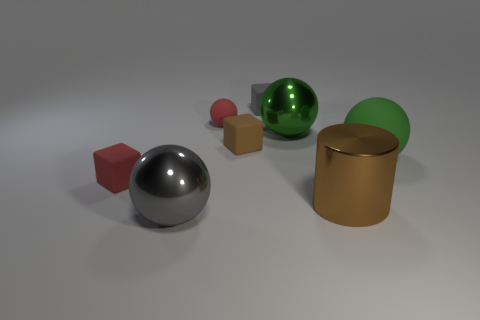Subtract all brown cylinders. How many green spheres are left? 2 Subtract all red balls. How many balls are left? 3 Subtract all tiny matte spheres. How many spheres are left? 3 Add 1 large brown objects. How many objects exist? 9 Subtract all red spheres. Subtract all blue cubes. How many spheres are left? 3 Subtract all cubes. How many objects are left? 5 Subtract 0 cyan balls. How many objects are left? 8 Subtract all small gray objects. Subtract all large green metal spheres. How many objects are left? 6 Add 5 large rubber spheres. How many large rubber spheres are left? 6 Add 5 large spheres. How many large spheres exist? 8 